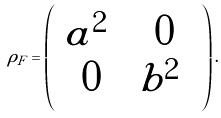Convert formula to latex. <formula><loc_0><loc_0><loc_500><loc_500>\rho _ { F } = \left ( \begin{array} { c c } | a | ^ { 2 } & 0 \\ 0 & | b | ^ { 2 } \end{array} \right ) .</formula> 